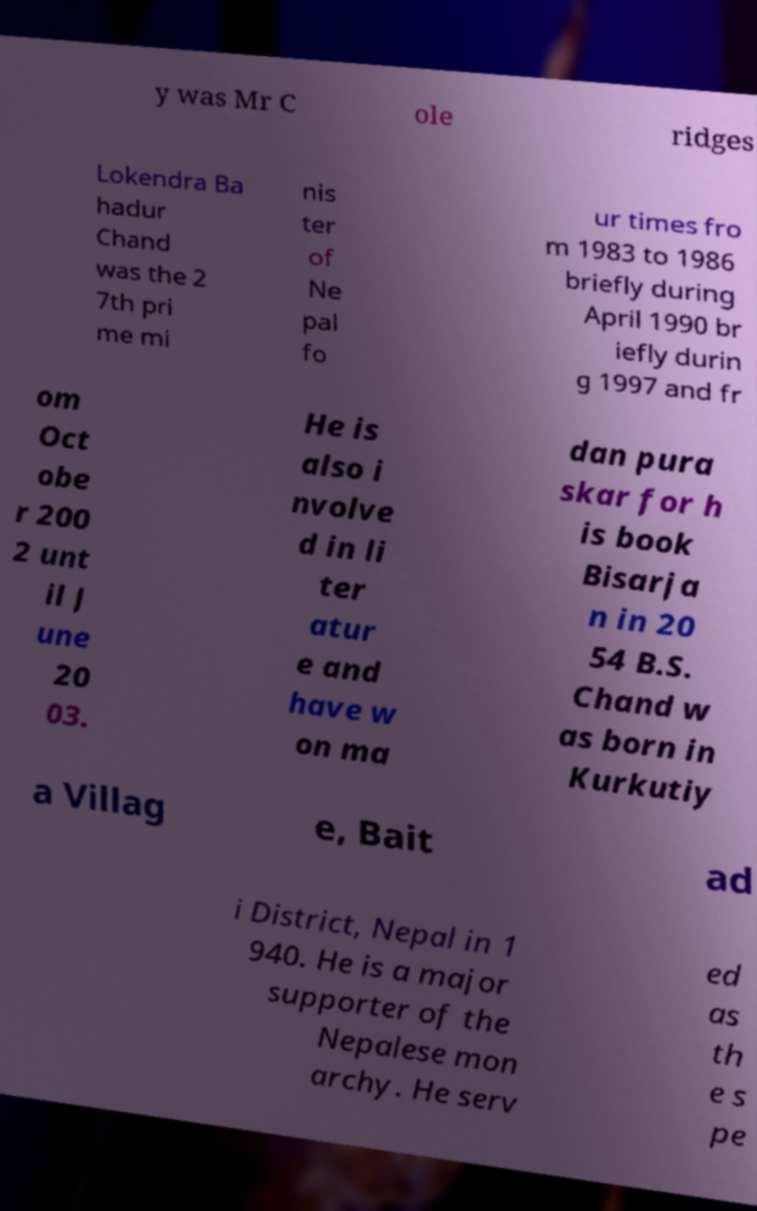I need the written content from this picture converted into text. Can you do that? y was Mr C ole ridges Lokendra Ba hadur Chand was the 2 7th pri me mi nis ter of Ne pal fo ur times fro m 1983 to 1986 briefly during April 1990 br iefly durin g 1997 and fr om Oct obe r 200 2 unt il J une 20 03. He is also i nvolve d in li ter atur e and have w on ma dan pura skar for h is book Bisarja n in 20 54 B.S. Chand w as born in Kurkutiy a Villag e, Bait ad i District, Nepal in 1 940. He is a major supporter of the Nepalese mon archy. He serv ed as th e s pe 